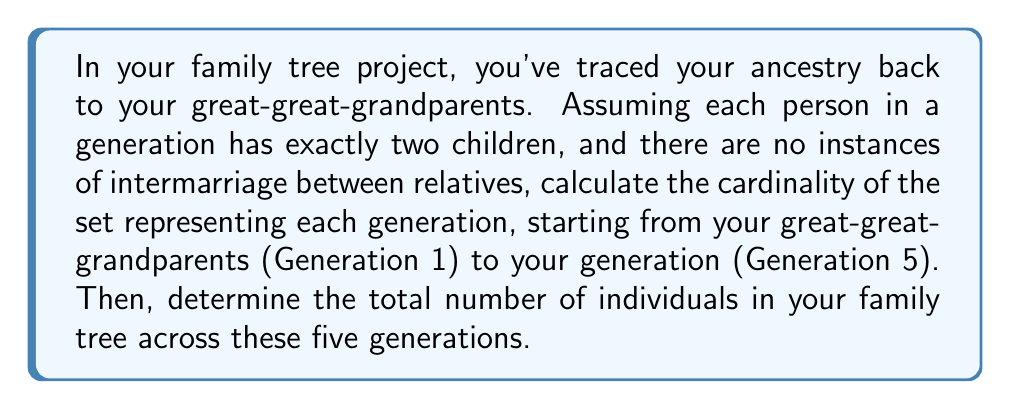Could you help me with this problem? Let's approach this step-by-step:

1) We start with Generation 1 (great-great-grandparents):
   - This is the oldest generation in our tree.
   - Let's denote the cardinality of this set as $|G_1|$.
   - In a complete binary tree structure, this would be 16 individuals.
   - So, $|G_1| = 16$

2) For Generation 2 (great-grandparents):
   - Each pair in Generation 1 has exactly two children.
   - So, $|G_2| = \frac{1}{2}|G_1| = \frac{1}{2} \cdot 16 = 8$

3) For Generation 3 (grandparents):
   - Again, each pair in Generation 2 has two children.
   - $|G_3| = \frac{1}{2}|G_2| = \frac{1}{2} \cdot 8 = 4$

4) For Generation 4 (parents):
   - $|G_4| = \frac{1}{2}|G_3| = \frac{1}{2} \cdot 4 = 2$

5) For Generation 5 (your generation):
   - $|G_5| = \frac{1}{2}|G_4| = \frac{1}{2} \cdot 2 = 1$

6) To find the total number of individuals, we sum the cardinalities of all sets:

   $$\text{Total} = |G_1| + |G_2| + |G_3| + |G_4| + |G_5|$$
   $$= 16 + 8 + 4 + 2 + 1 = 31$$

Therefore, there are 31 individuals in total across these five generations in your family tree.
Answer: The cardinalities of the sets representing each generation are:
Generation 1 (great-great-grandparents): $|G_1| = 16$
Generation 2 (great-grandparents): $|G_2| = 8$
Generation 3 (grandparents): $|G_3| = 4$
Generation 4 (parents): $|G_4| = 2$
Generation 5 (your generation): $|G_5| = 1$

The total number of individuals across all five generations is 31. 